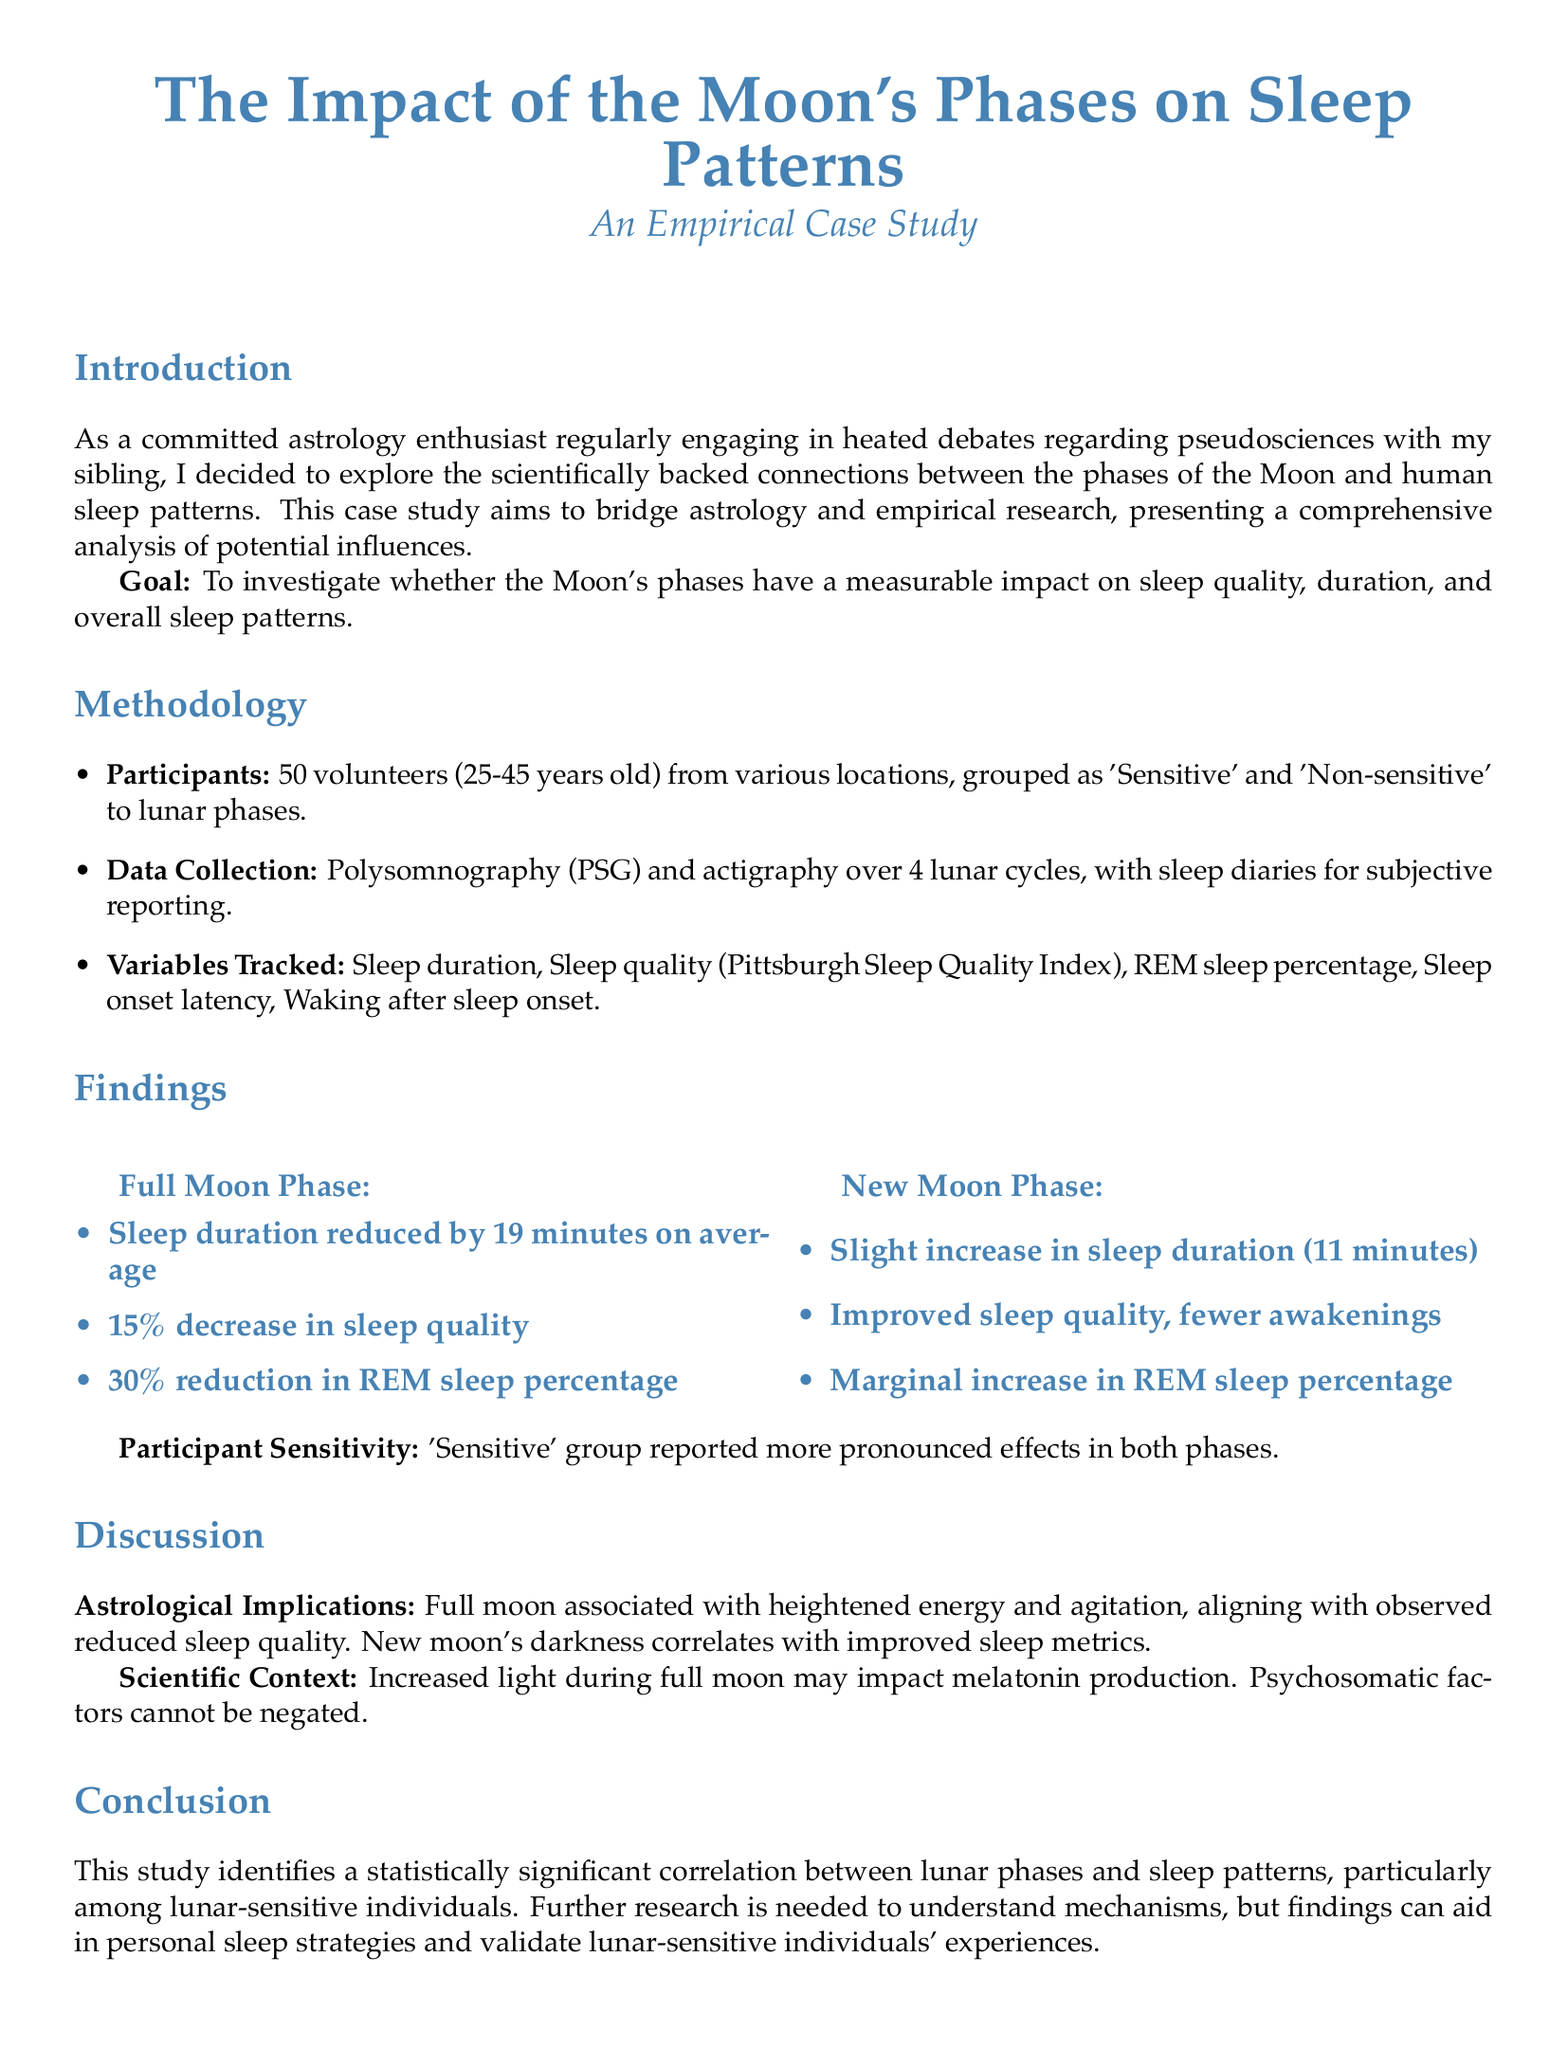what is the goal of the case study? The goal is to investigate whether the Moon's phases have a measurable impact on sleep quality, duration, and overall sleep patterns.
Answer: To investigate the Moon's phases' impact on sleep how many volunteers participated in the study? The document states that there were 50 volunteers involved in the case study.
Answer: 50 what type of sleep measurement was used? The sleep measurement used in the study included polysomnography (PSG) and actigraphy.
Answer: Polysomnography and actigraphy what was the average reduction in sleep duration during the full moon phase? The average reduction in sleep duration during the full moon phase was 19 minutes.
Answer: 19 minutes what effect did the new moon phase have on sleep quality? The new moon phase was associated with improved sleep quality and fewer awakenings.
Answer: Improved sleep quality which group reported more pronounced effects during lunar phases? The 'Sensitive' group reported more pronounced effects during both the full and new moon phases.
Answer: 'Sensitive' group how much did REM sleep percentage decrease during the full moon phase? During the full moon phase, there was a 30% reduction in REM sleep percentage.
Answer: 30% what is the relation between the full moon and sleep quality according to the study? The full moon is associated with heightened energy and agitation, leading to reduced sleep quality.
Answer: Reduced sleep quality how many lunar cycles did the study observe? The study collected data over 4 lunar cycles.
Answer: 4 lunar cycles 